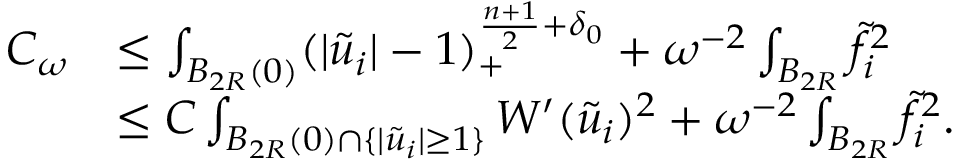<formula> <loc_0><loc_0><loc_500><loc_500>\begin{array} { r l } { C _ { \omega } } & { \leq \int _ { B _ { 2 R } ( 0 ) } ( | \tilde { u } _ { i } | - 1 ) _ { + } ^ { \frac { n + 1 } { 2 } + \delta _ { 0 } } + \omega ^ { - 2 } \int _ { B _ { 2 R } } \tilde { f } _ { i } ^ { 2 } } \\ & { \leq C \int _ { B _ { 2 R } ( 0 ) \cap \{ | \tilde { u } _ { i } | \geq 1 \} } W ^ { \prime } ( \tilde { u } _ { i } ) ^ { 2 } + \omega ^ { - 2 } \int _ { B _ { 2 R } } \tilde { f } _ { i } ^ { 2 } . } \end{array}</formula> 